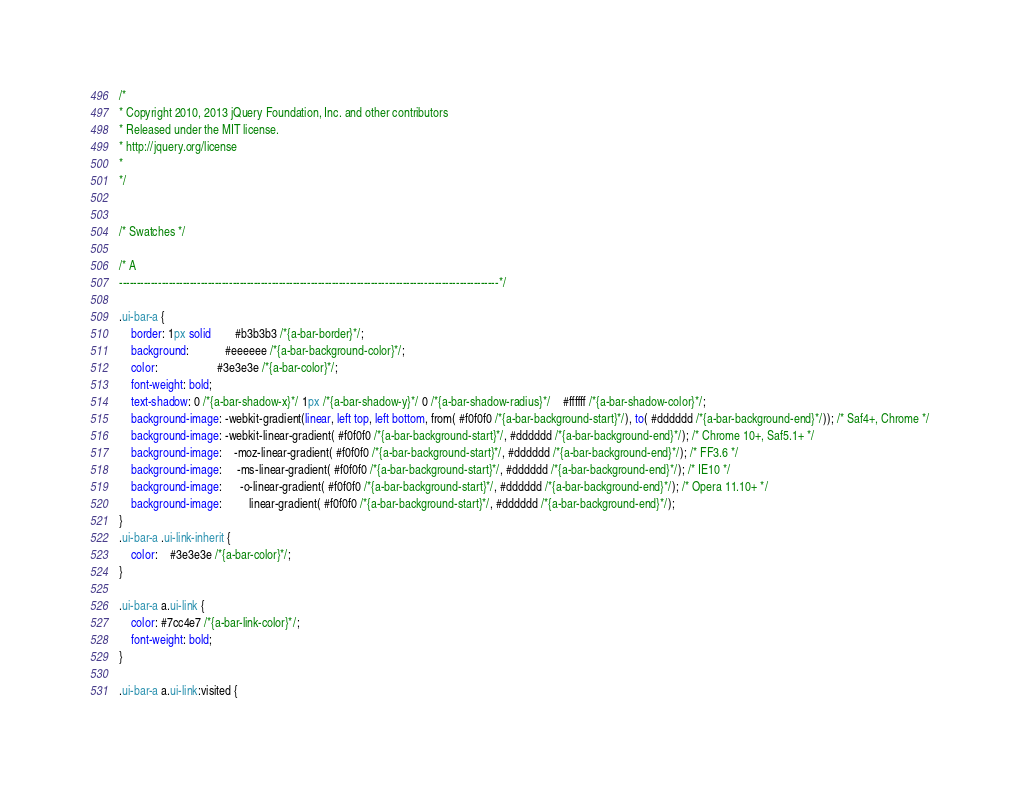Convert code to text. <code><loc_0><loc_0><loc_500><loc_500><_CSS_>/*
* Copyright 2010, 2013 jQuery Foundation, Inc. and other contributors
* Released under the MIT license.
* http://jquery.org/license
*
*/


/* Swatches */

/* A
-----------------------------------------------------------------------------------------------------------*/

.ui-bar-a {
	border: 1px solid 		#b3b3b3 /*{a-bar-border}*/;
	background: 			#eeeeee /*{a-bar-background-color}*/;
	color: 					#3e3e3e /*{a-bar-color}*/;
	font-weight: bold;
	text-shadow: 0 /*{a-bar-shadow-x}*/ 1px /*{a-bar-shadow-y}*/ 0 /*{a-bar-shadow-radius}*/ 	#ffffff /*{a-bar-shadow-color}*/;
	background-image: -webkit-gradient(linear, left top, left bottom, from( #f0f0f0 /*{a-bar-background-start}*/), to( #dddddd /*{a-bar-background-end}*/)); /* Saf4+, Chrome */
	background-image: -webkit-linear-gradient( #f0f0f0 /*{a-bar-background-start}*/, #dddddd /*{a-bar-background-end}*/); /* Chrome 10+, Saf5.1+ */
	background-image:    -moz-linear-gradient( #f0f0f0 /*{a-bar-background-start}*/, #dddddd /*{a-bar-background-end}*/); /* FF3.6 */
	background-image:     -ms-linear-gradient( #f0f0f0 /*{a-bar-background-start}*/, #dddddd /*{a-bar-background-end}*/); /* IE10 */
	background-image:      -o-linear-gradient( #f0f0f0 /*{a-bar-background-start}*/, #dddddd /*{a-bar-background-end}*/); /* Opera 11.10+ */
	background-image:         linear-gradient( #f0f0f0 /*{a-bar-background-start}*/, #dddddd /*{a-bar-background-end}*/);
}
.ui-bar-a .ui-link-inherit {
	color: 	#3e3e3e /*{a-bar-color}*/;
}

.ui-bar-a a.ui-link {
	color: #7cc4e7 /*{a-bar-link-color}*/;
	font-weight: bold;
}

.ui-bar-a a.ui-link:visited {</code> 